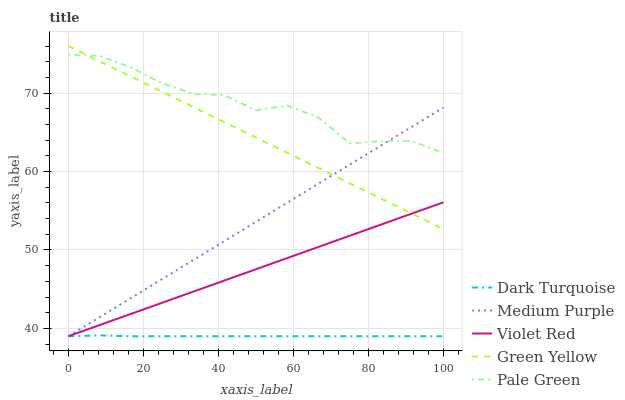Does Violet Red have the minimum area under the curve?
Answer yes or no. No. Does Violet Red have the maximum area under the curve?
Answer yes or no. No. Is Dark Turquoise the smoothest?
Answer yes or no. No. Is Dark Turquoise the roughest?
Answer yes or no. No. Does Green Yellow have the lowest value?
Answer yes or no. No. Does Violet Red have the highest value?
Answer yes or no. No. Is Dark Turquoise less than Pale Green?
Answer yes or no. Yes. Is Pale Green greater than Violet Red?
Answer yes or no. Yes. Does Dark Turquoise intersect Pale Green?
Answer yes or no. No. 